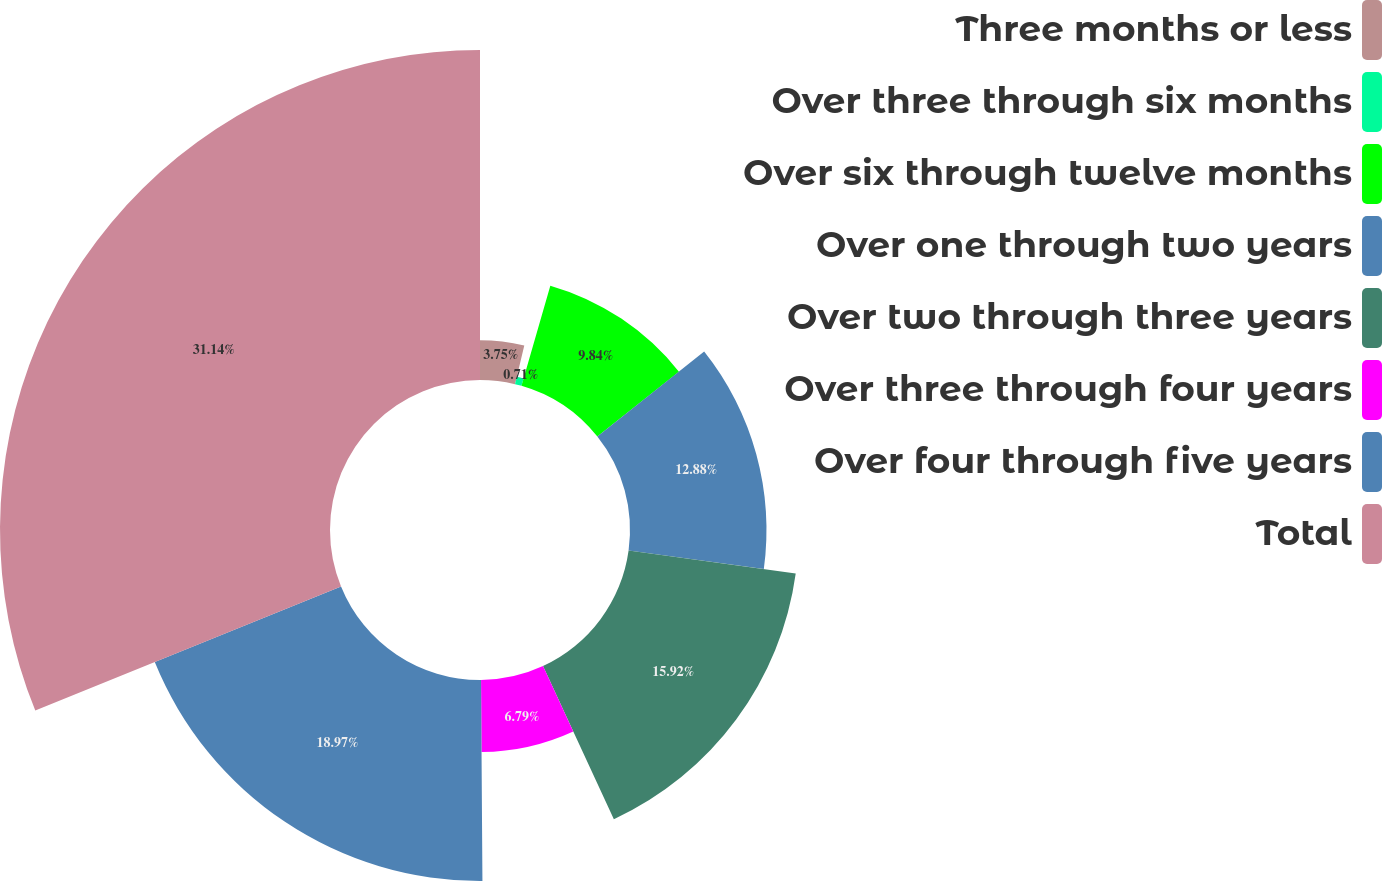<chart> <loc_0><loc_0><loc_500><loc_500><pie_chart><fcel>Three months or less<fcel>Over three through six months<fcel>Over six through twelve months<fcel>Over one through two years<fcel>Over two through three years<fcel>Over three through four years<fcel>Over four through five years<fcel>Total<nl><fcel>3.75%<fcel>0.71%<fcel>9.84%<fcel>12.88%<fcel>15.92%<fcel>6.79%<fcel>18.97%<fcel>31.14%<nl></chart> 